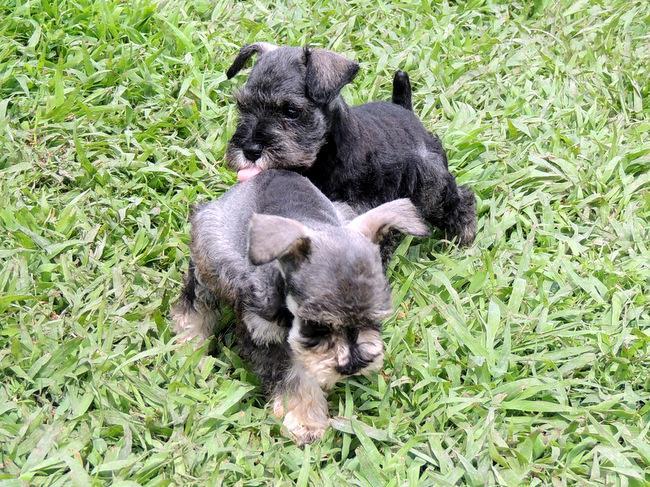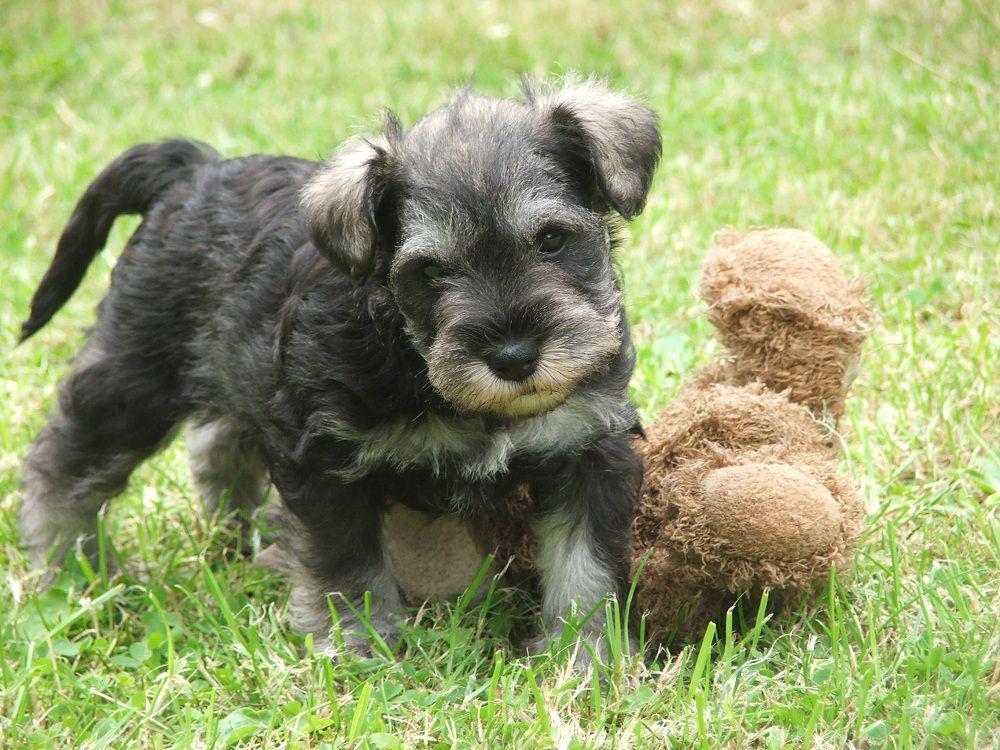The first image is the image on the left, the second image is the image on the right. Assess this claim about the two images: "A long haired light colored dog is standing outside in the grass on a leash.". Correct or not? Answer yes or no. No. The first image is the image on the left, the second image is the image on the right. Given the left and right images, does the statement "a dog is standing in the grass with a taught leash" hold true? Answer yes or no. No. 